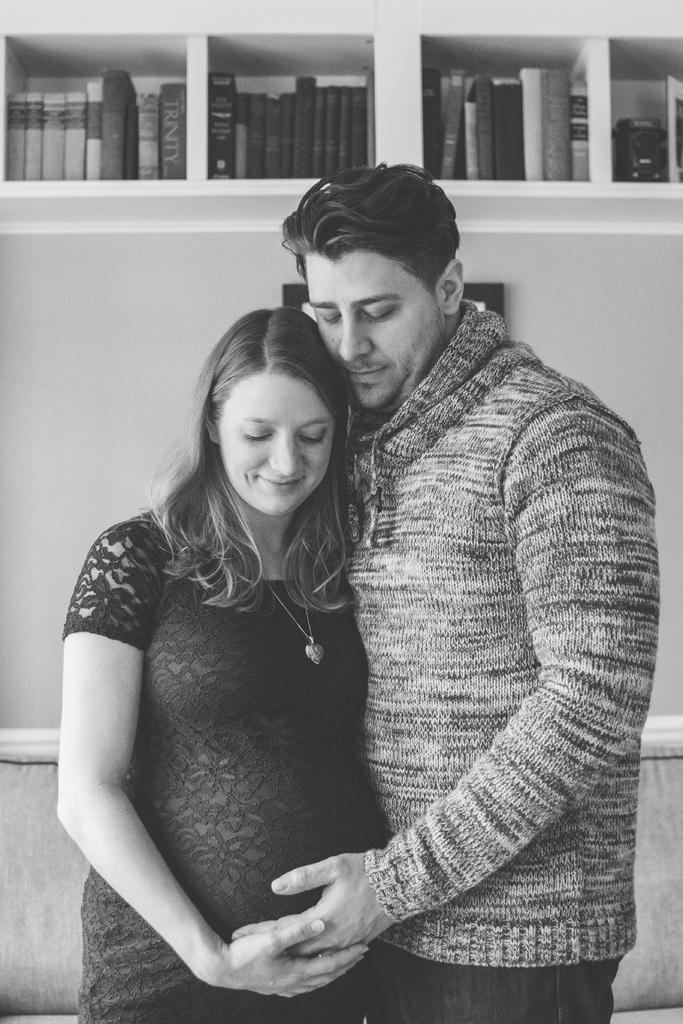What is the color scheme of the image? The image is black and white. What are the people in the image doing? There is a man standing and smiling, and a woman standing and smiling in the image. What can be seen on the wall in the image? There is a wall visible in the image. What type of furniture is present in the image? There is a couch in the image. What might be used for organizing and storing in the image? There are books placed in a rack in the image. What type of verse can be heard being recited in the image? There is no indication in the image that any verse is being recited, as the image is silent and does not contain any audio. What type of stove is visible in the image? There is no stove present in the image. 